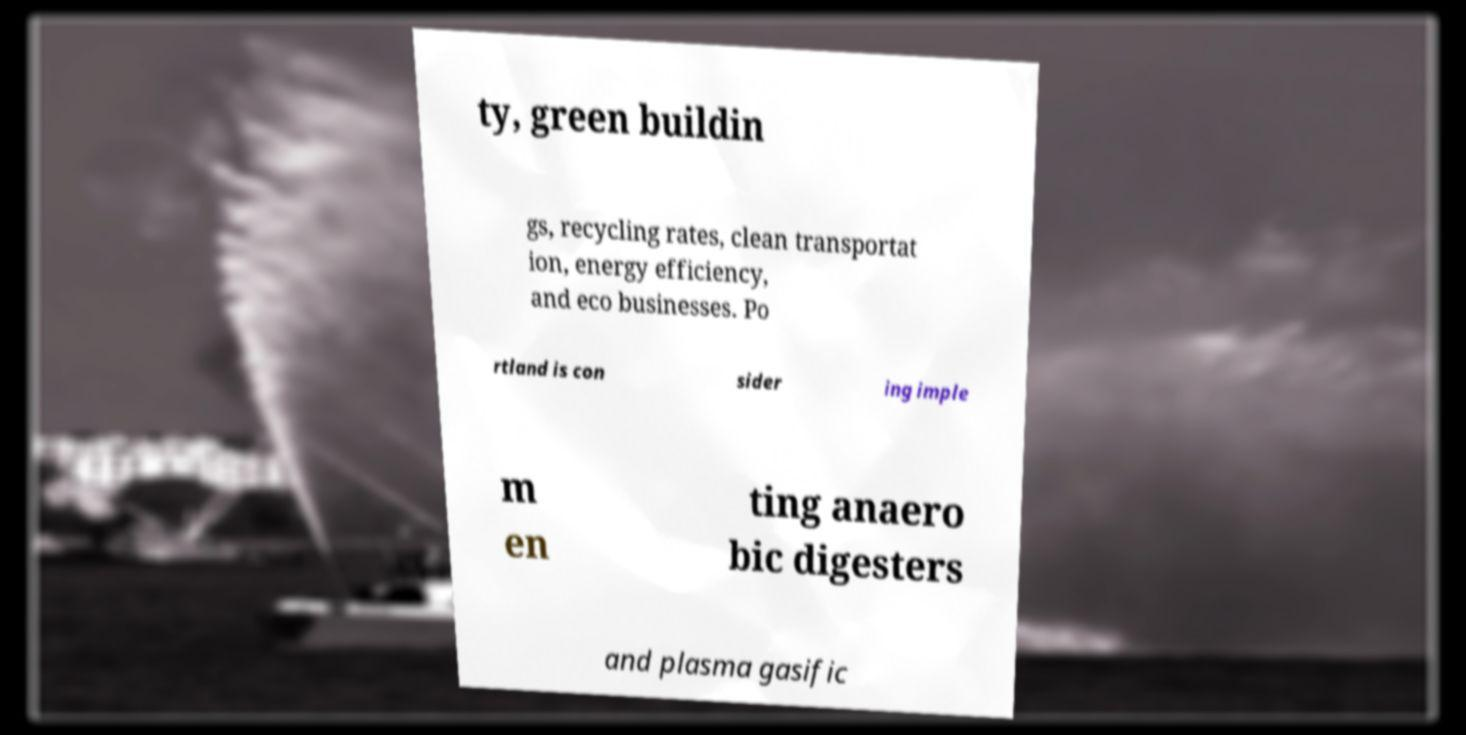Can you read and provide the text displayed in the image?This photo seems to have some interesting text. Can you extract and type it out for me? ty, green buildin gs, recycling rates, clean transportat ion, energy efficiency, and eco businesses. Po rtland is con sider ing imple m en ting anaero bic digesters and plasma gasific 